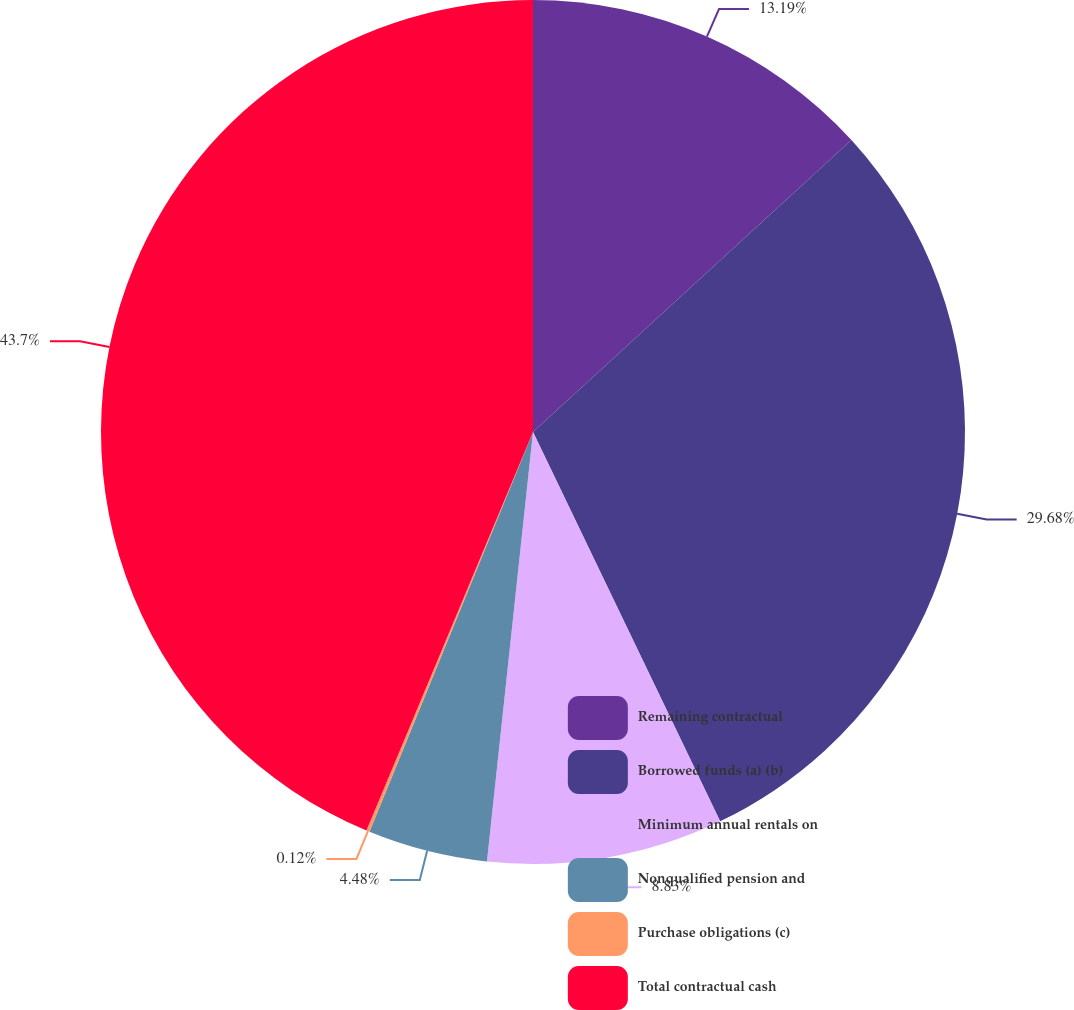Convert chart to OTSL. <chart><loc_0><loc_0><loc_500><loc_500><pie_chart><fcel>Remaining contractual<fcel>Borrowed funds (a) (b)<fcel>Minimum annual rentals on<fcel>Nonqualified pension and<fcel>Purchase obligations (c)<fcel>Total contractual cash<nl><fcel>13.19%<fcel>29.68%<fcel>8.83%<fcel>4.48%<fcel>0.12%<fcel>43.7%<nl></chart> 